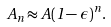Convert formula to latex. <formula><loc_0><loc_0><loc_500><loc_500>A _ { n } \approx A ( 1 - \epsilon ) ^ { n } \, .</formula> 